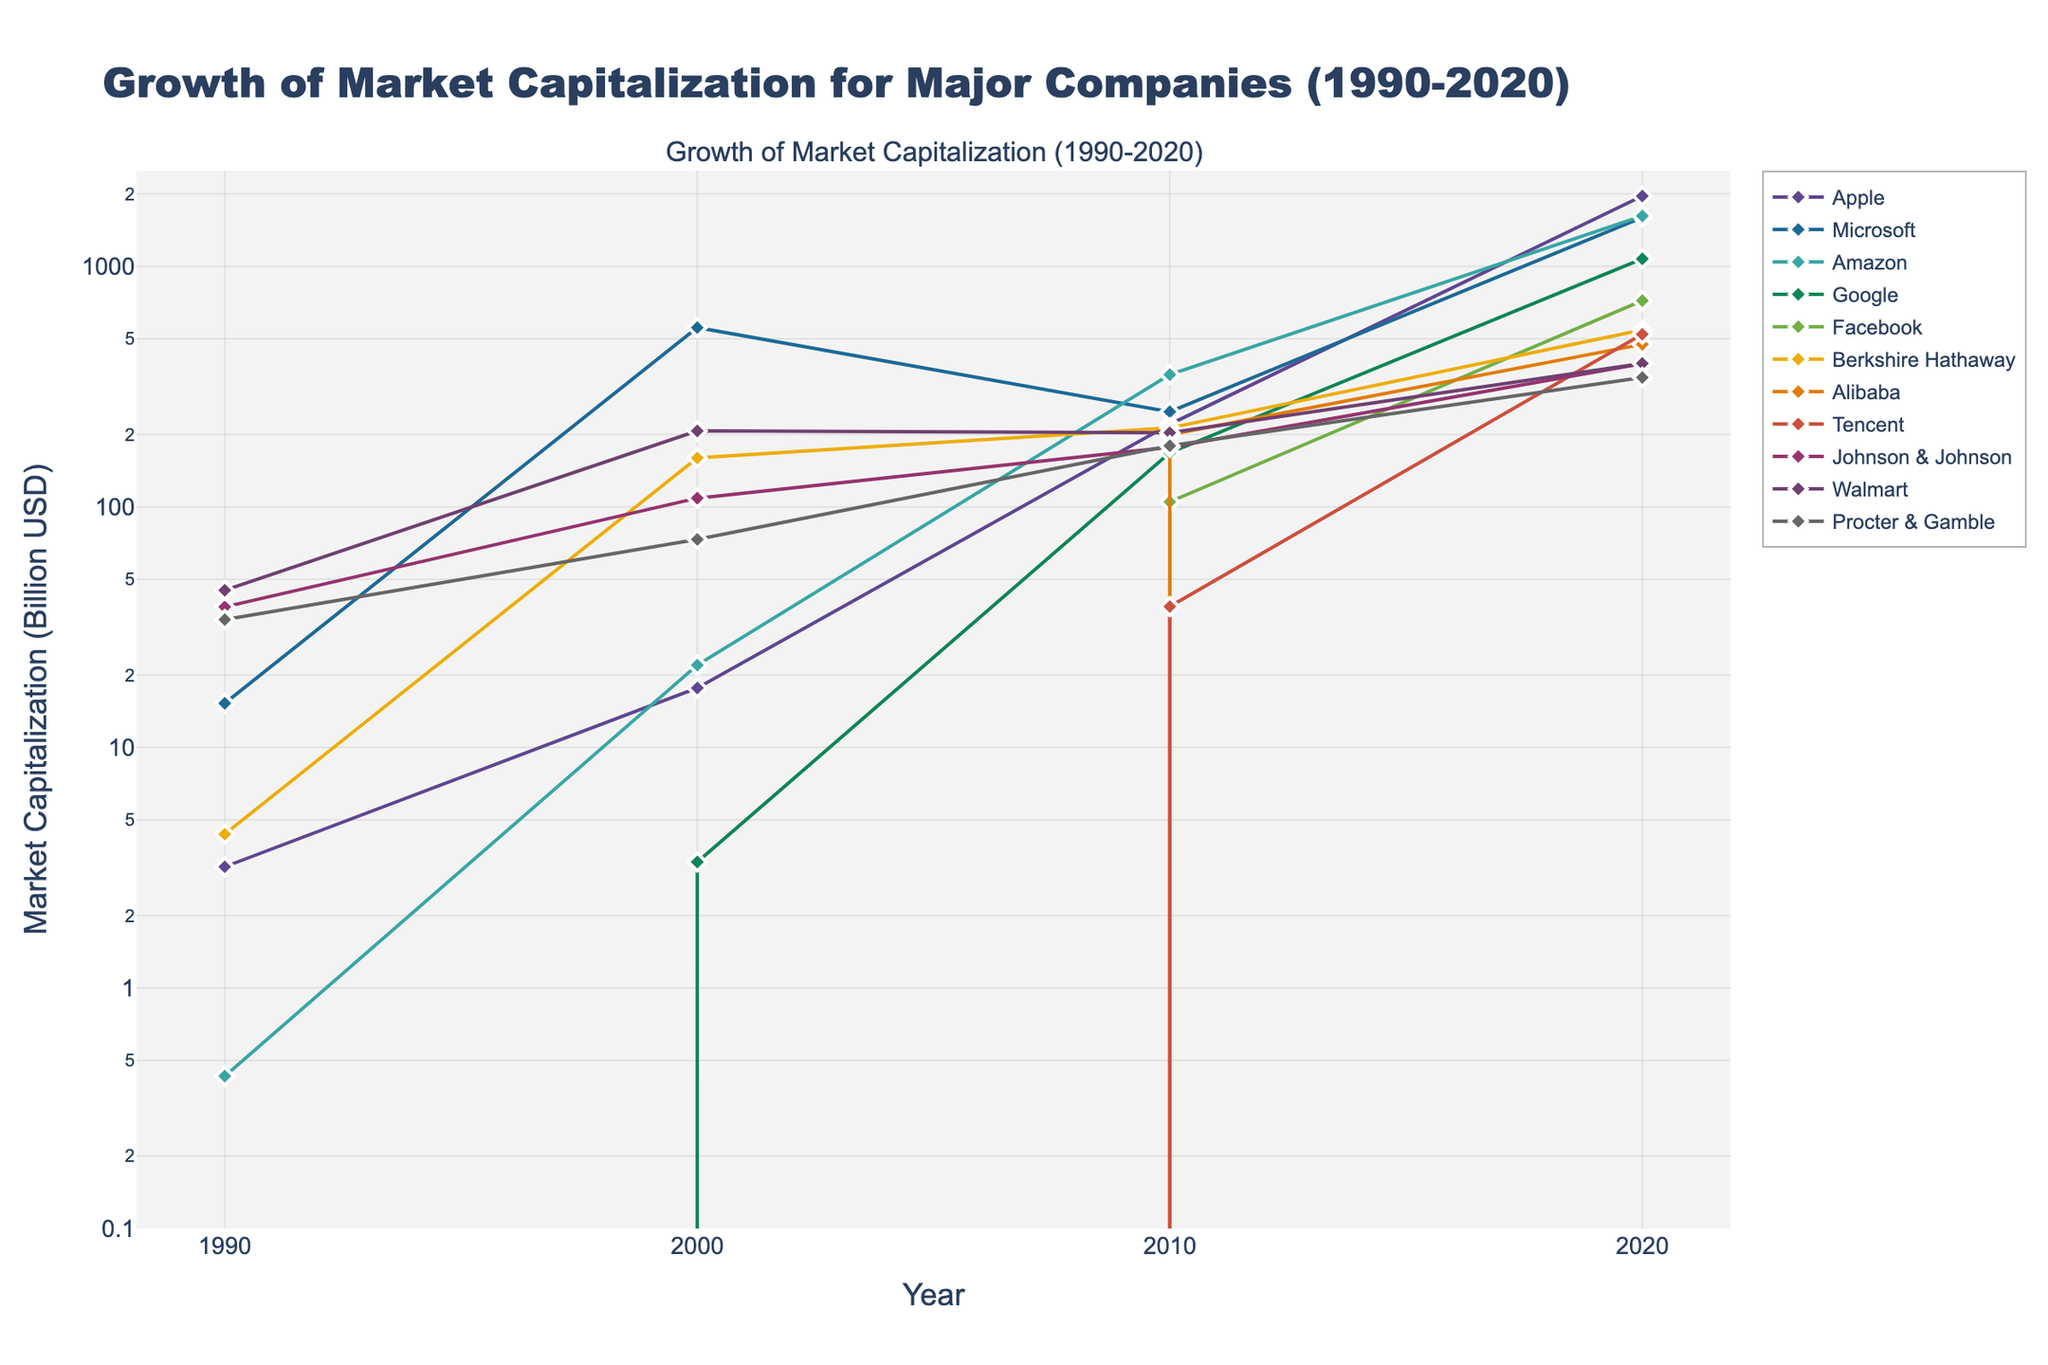How many companies are shown in the plot? The plot contains lines for each company listed in the dataset. Count the number of distinct lines or markers representing different companies.
Answer: 11 What is the market capitalization of Apple in 2020? Locate the line representing Apple on the plot and find the data point at the year 2020. Look at the value on the y-axis in log scale to identify Apple's market cap.
Answer: 1960 billion USD Which company had the highest market capitalization in 2000? Examine the plot and compare the market capitalization values at the year 2000 for all companies. The y-axis will indicate the values.
Answer: Microsoft How much did Amazon's market cap grow from 2000 to 2020? Identify Amazon's market cap values in the years 2000 and 2020. Subtract the value in 2000 from the value in 2020 to find the growth.
Answer: 1598 billion USD Which companies had no market capitalization before 2000 and show significant growth afterward? Look at the lines starting from zero in 1990 and rising significantly in 2000, 2010, and 2020. Check the y-axis for market cap growth.
Answer: Amazon, Google, Facebook, Alibaba, Tencent By what factor did Microsoft's market cap increase from 1990 to 2000? Find Microsoft's market capitalization values for 1990 and 2000. Divide the 2000 value by the 1990 value to calculate the growth factor.
Answer: Approximately 36.45 Compare the market capitalization of Walmart and Johnson & Johnson in 2020. Who has a higher market cap? Locate the end points of Walmart and Johnson & Johnson lines for the year 2020. Compare their y-axis values.
Answer: Walmart Which company shows the smallest growth between 2000 and 2010? Look at the segment of each company's line between 2000 and 2010. Identify the company with the least change in y-axis (log scale) values.
Answer: Walmart How does the logarithmic scale affect the appearance of market capitalization growth for all companies? Evaluate how lines appear on a logarithmic scale, noting the gradual change representation rather than rapid exponential increases.
Answer: It compresses exponential growth into a more linear appearance What's the trend of Procter & Gamble's market cap over the time span? Follow the line representing Procter & Gamble from 1990 to 2020, noting the changes in market cap at each observed year.
Answer: General increase with fluctuations 